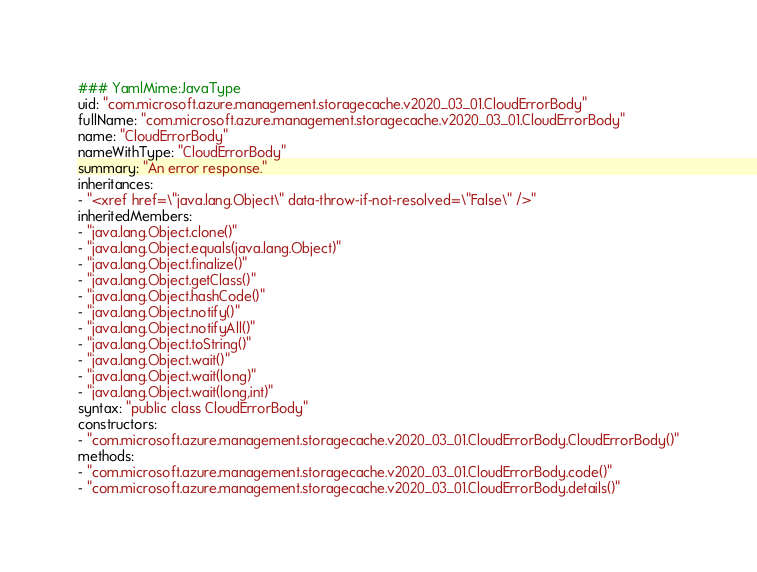Convert code to text. <code><loc_0><loc_0><loc_500><loc_500><_YAML_>### YamlMime:JavaType
uid: "com.microsoft.azure.management.storagecache.v2020_03_01.CloudErrorBody"
fullName: "com.microsoft.azure.management.storagecache.v2020_03_01.CloudErrorBody"
name: "CloudErrorBody"
nameWithType: "CloudErrorBody"
summary: "An error response."
inheritances:
- "<xref href=\"java.lang.Object\" data-throw-if-not-resolved=\"False\" />"
inheritedMembers:
- "java.lang.Object.clone()"
- "java.lang.Object.equals(java.lang.Object)"
- "java.lang.Object.finalize()"
- "java.lang.Object.getClass()"
- "java.lang.Object.hashCode()"
- "java.lang.Object.notify()"
- "java.lang.Object.notifyAll()"
- "java.lang.Object.toString()"
- "java.lang.Object.wait()"
- "java.lang.Object.wait(long)"
- "java.lang.Object.wait(long,int)"
syntax: "public class CloudErrorBody"
constructors:
- "com.microsoft.azure.management.storagecache.v2020_03_01.CloudErrorBody.CloudErrorBody()"
methods:
- "com.microsoft.azure.management.storagecache.v2020_03_01.CloudErrorBody.code()"
- "com.microsoft.azure.management.storagecache.v2020_03_01.CloudErrorBody.details()"</code> 